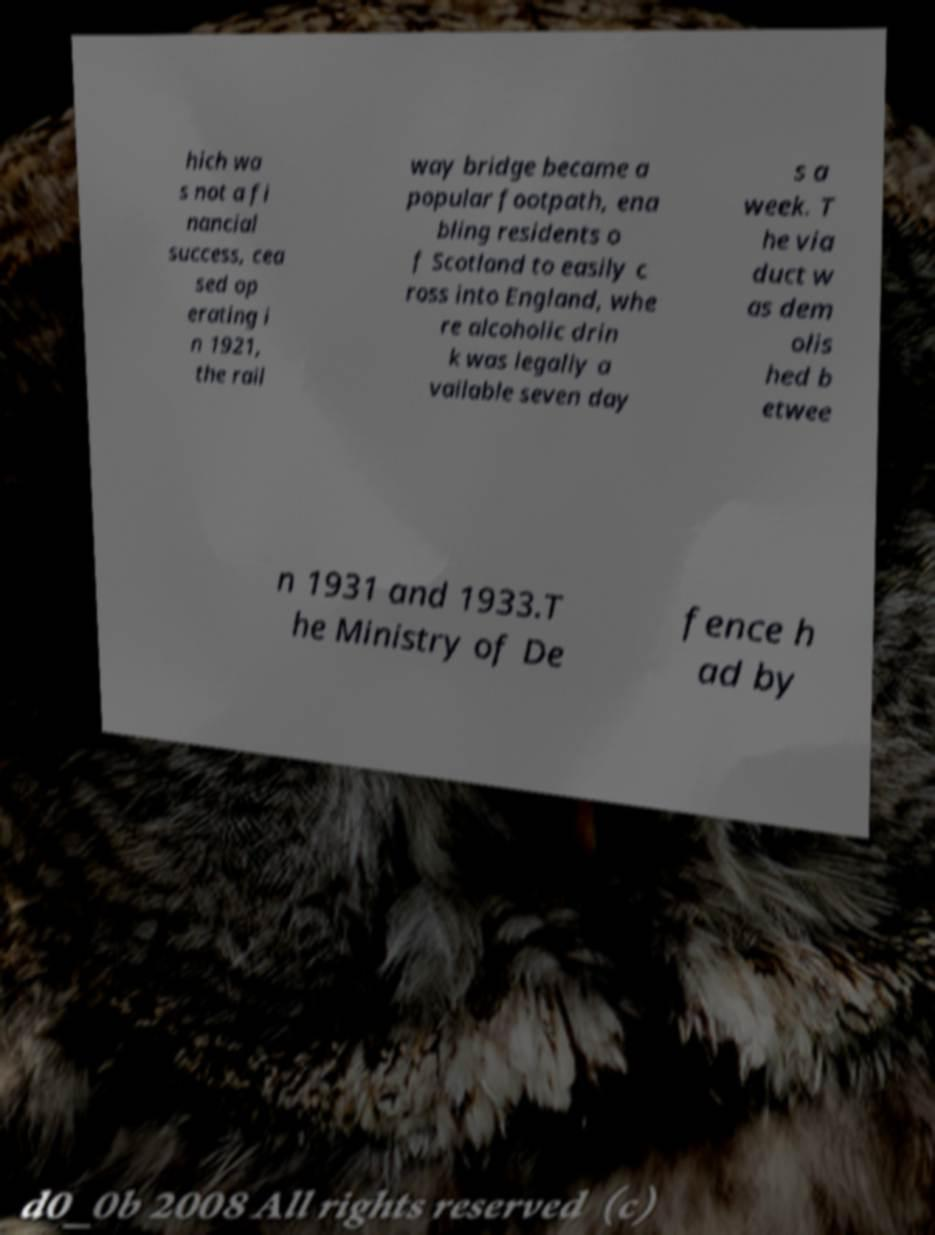Could you extract and type out the text from this image? hich wa s not a fi nancial success, cea sed op erating i n 1921, the rail way bridge became a popular footpath, ena bling residents o f Scotland to easily c ross into England, whe re alcoholic drin k was legally a vailable seven day s a week. T he via duct w as dem olis hed b etwee n 1931 and 1933.T he Ministry of De fence h ad by 